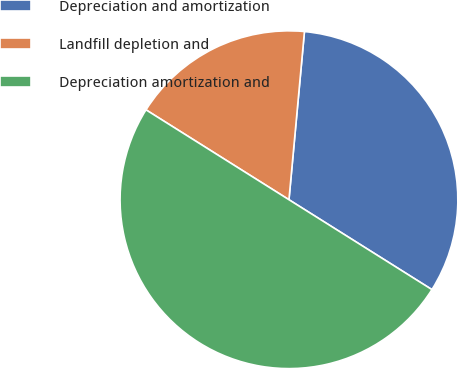Convert chart. <chart><loc_0><loc_0><loc_500><loc_500><pie_chart><fcel>Depreciation and amortization<fcel>Landfill depletion and<fcel>Depreciation amortization and<nl><fcel>32.47%<fcel>17.53%<fcel>50.0%<nl></chart> 